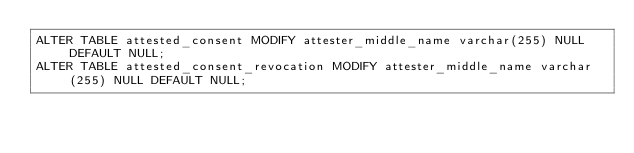<code> <loc_0><loc_0><loc_500><loc_500><_SQL_>ALTER TABLE attested_consent MODIFY attester_middle_name varchar(255) NULL DEFAULT NULL;
ALTER TABLE attested_consent_revocation MODIFY attester_middle_name varchar(255) NULL DEFAULT NULL;</code> 